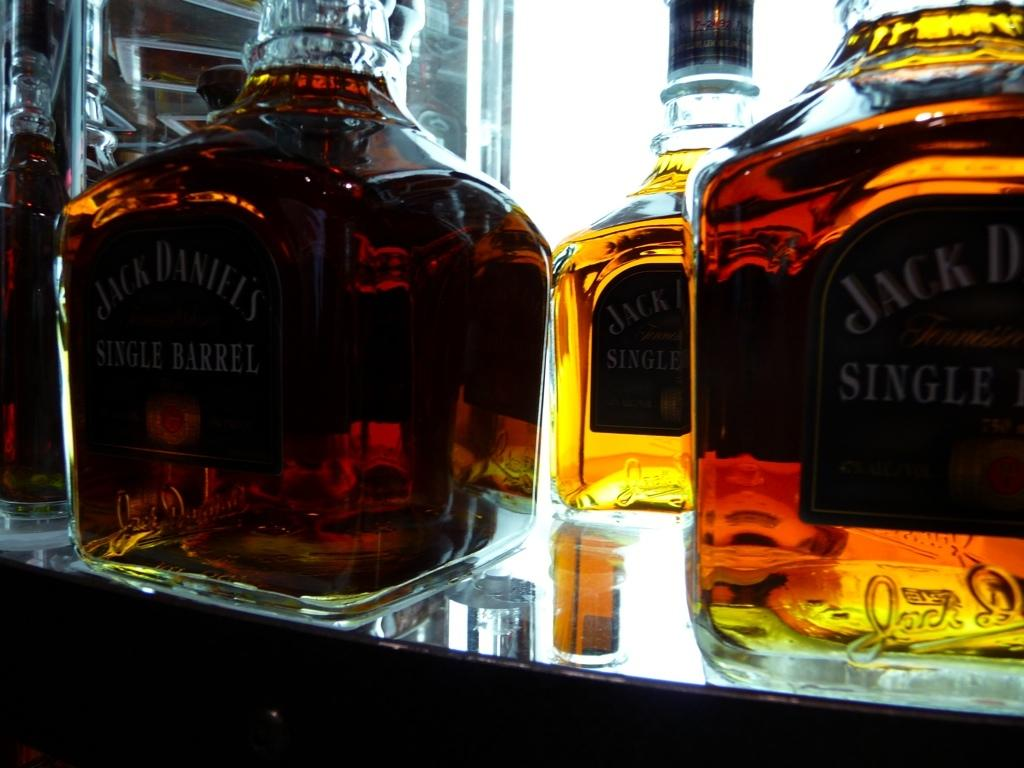What type of containers are visible in the image? There are glass bottles in the image. Where are the glass bottles located? The glass bottles are on a table. What type of basket is visible in the image? There is no basket present in the image. What is the opinion of the glass bottles in the image? The image does not convey any opinions about the glass bottles; it simply shows their presence on a table. 